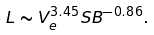<formula> <loc_0><loc_0><loc_500><loc_500>L \sim V _ { e } ^ { 3 . 4 5 } S B ^ { - 0 . 8 6 } .</formula> 